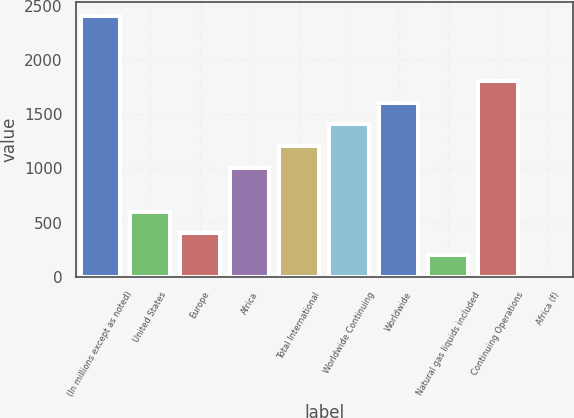Convert chart to OTSL. <chart><loc_0><loc_0><loc_500><loc_500><bar_chart><fcel>(In millions except as noted)<fcel>United States<fcel>Europe<fcel>Africa<fcel>Total International<fcel>Worldwide Continuing<fcel>Worldwide<fcel>Natural gas liquids included<fcel>Continuing Operations<fcel>Africa (f)<nl><fcel>2408.36<fcel>602.29<fcel>401.61<fcel>1003.63<fcel>1204.31<fcel>1404.98<fcel>1605.65<fcel>200.93<fcel>1806.33<fcel>0.25<nl></chart> 